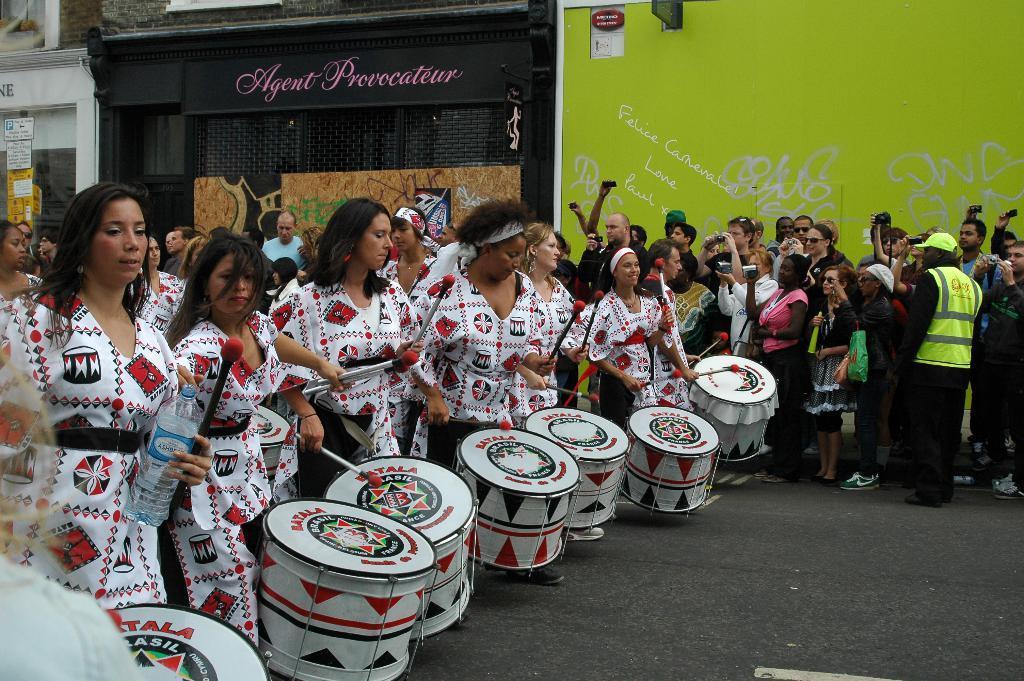Can you describe this image briefly? here in this picture there are woman standing on the road and playing drums ,some people are standing away taking pictures and encouraging we can also see the rooms, walls and text. 